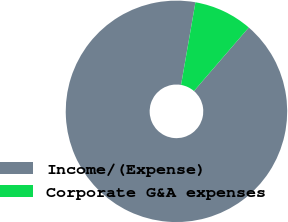Convert chart. <chart><loc_0><loc_0><loc_500><loc_500><pie_chart><fcel>Income/(Expense)<fcel>Corporate G&A expenses<nl><fcel>91.42%<fcel>8.58%<nl></chart> 